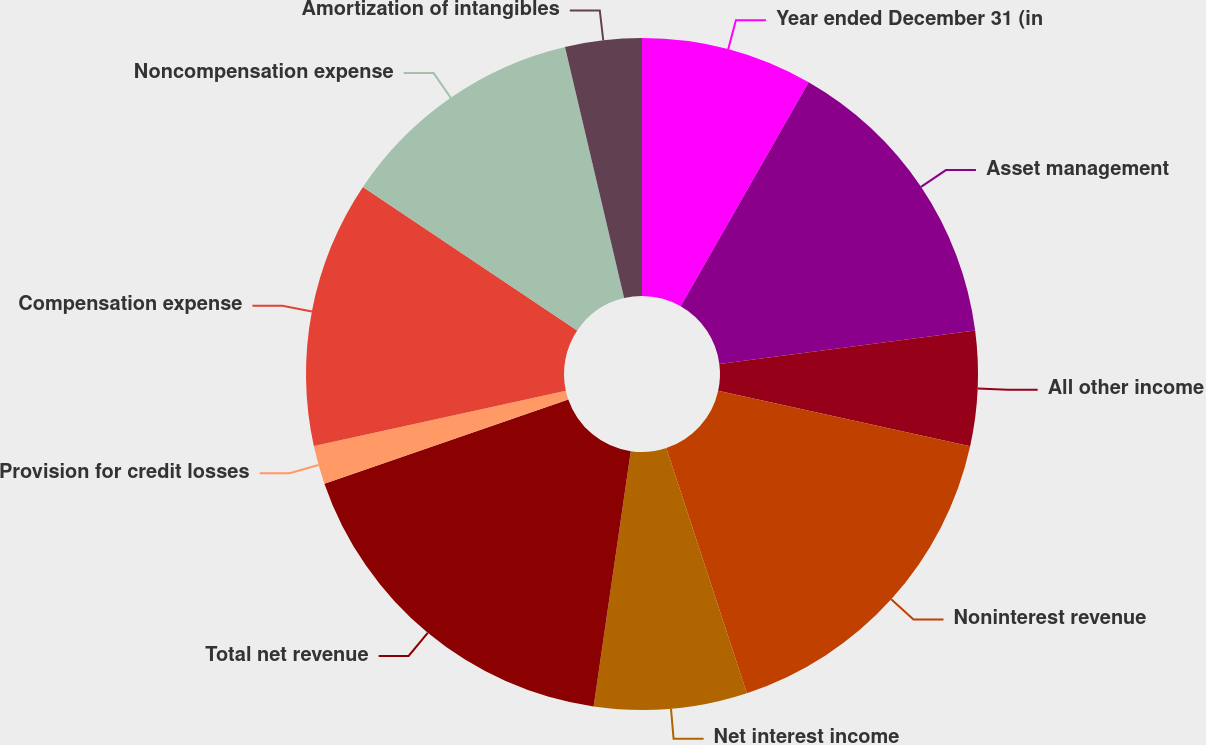<chart> <loc_0><loc_0><loc_500><loc_500><pie_chart><fcel>Year ended December 31 (in<fcel>Asset management<fcel>All other income<fcel>Noninterest revenue<fcel>Net interest income<fcel>Total net revenue<fcel>Provision for credit losses<fcel>Compensation expense<fcel>Noncompensation expense<fcel>Amortization of intangibles<nl><fcel>8.26%<fcel>14.67%<fcel>5.52%<fcel>16.5%<fcel>7.35%<fcel>17.41%<fcel>1.85%<fcel>12.84%<fcel>11.92%<fcel>3.68%<nl></chart> 